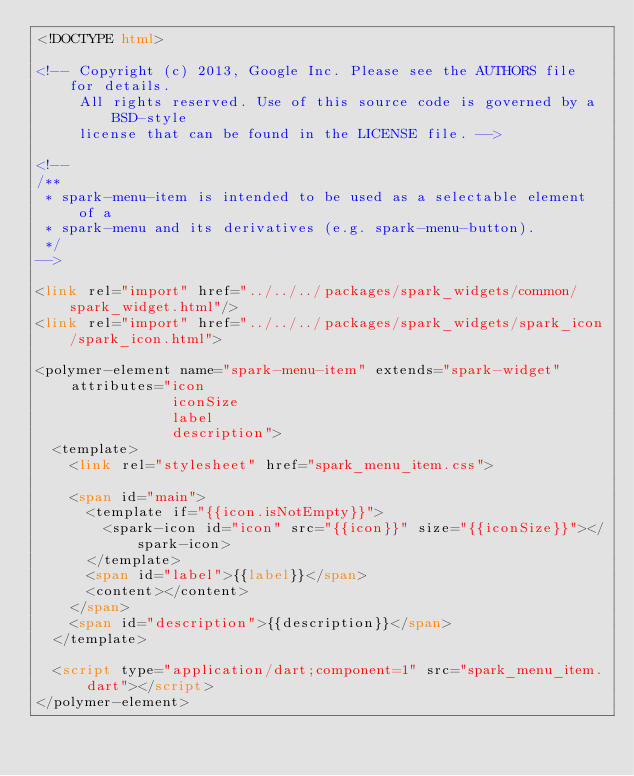<code> <loc_0><loc_0><loc_500><loc_500><_HTML_><!DOCTYPE html>

<!-- Copyright (c) 2013, Google Inc. Please see the AUTHORS file for details.
     All rights reserved. Use of this source code is governed by a BSD-style
     license that can be found in the LICENSE file. -->

<!--
/**
 * spark-menu-item is intended to be used as a selectable element of a
 * spark-menu and its derivatives (e.g. spark-menu-button).
 */
-->

<link rel="import" href="../../../packages/spark_widgets/common/spark_widget.html"/>
<link rel="import" href="../../../packages/spark_widgets/spark_icon/spark_icon.html">

<polymer-element name="spark-menu-item" extends="spark-widget"
    attributes="icon
                iconSize
                label
                description">
  <template>
    <link rel="stylesheet" href="spark_menu_item.css">

    <span id="main">
      <template if="{{icon.isNotEmpty}}">
        <spark-icon id="icon" src="{{icon}}" size="{{iconSize}}"></spark-icon>
      </template>
      <span id="label">{{label}}</span>
      <content></content>
    </span>
    <span id="description">{{description}}</span>
  </template>

  <script type="application/dart;component=1" src="spark_menu_item.dart"></script>
</polymer-element>
</code> 